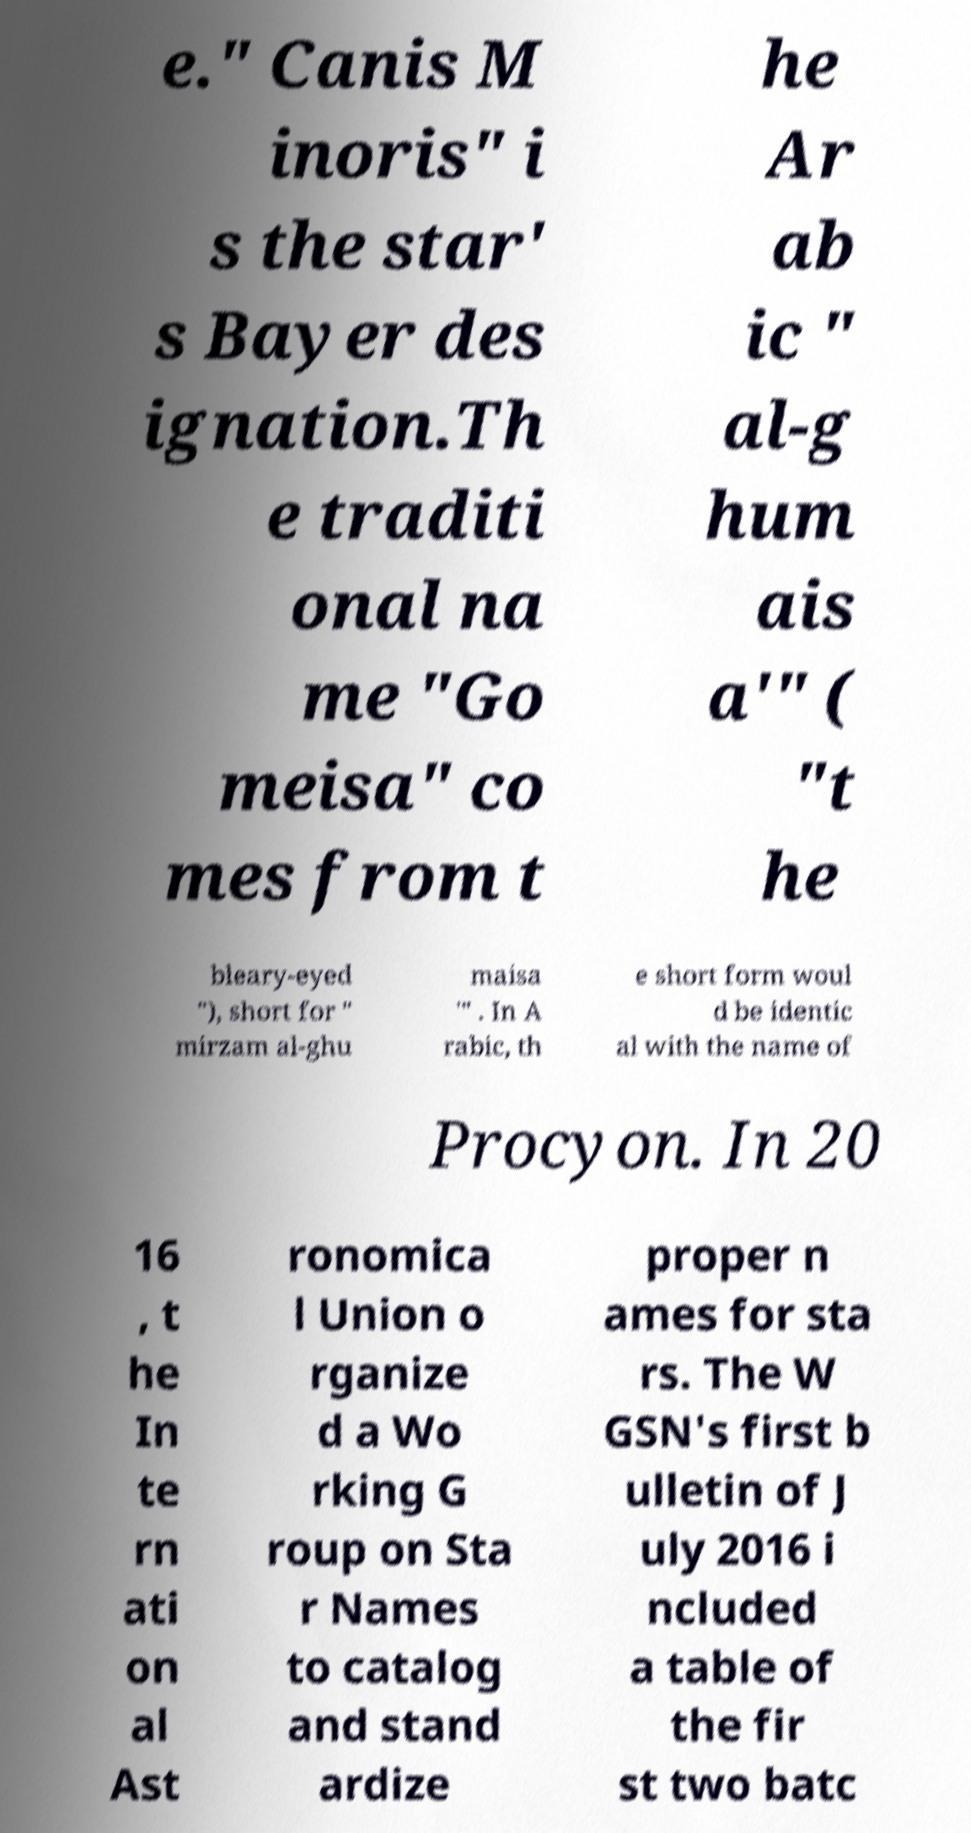Could you assist in decoding the text presented in this image and type it out clearly? e." Canis M inoris" i s the star' s Bayer des ignation.Th e traditi onal na me "Go meisa" co mes from t he Ar ab ic " al-g hum ais a'" ( "t he bleary-eyed "), short for " mirzam al-ghu maisa '" . In A rabic, th e short form woul d be identic al with the name of Procyon. In 20 16 , t he In te rn ati on al Ast ronomica l Union o rganize d a Wo rking G roup on Sta r Names to catalog and stand ardize proper n ames for sta rs. The W GSN's first b ulletin of J uly 2016 i ncluded a table of the fir st two batc 